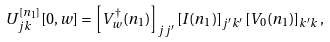<formula> <loc_0><loc_0><loc_500><loc_500>U ^ { [ n _ { 1 } ] } _ { j k } [ 0 , w ] = \left [ V _ { w } ^ { \dagger } ( n _ { 1 } ) \right ] _ { j j ^ { \prime } } [ I ( n _ { 1 } ) ] _ { j ^ { \prime } k ^ { \prime } } \left [ V _ { 0 } ( n _ { 1 } ) \right ] _ { k ^ { \prime } k } ,</formula> 